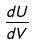<formula> <loc_0><loc_0><loc_500><loc_500>\frac { d U } { d V }</formula> 